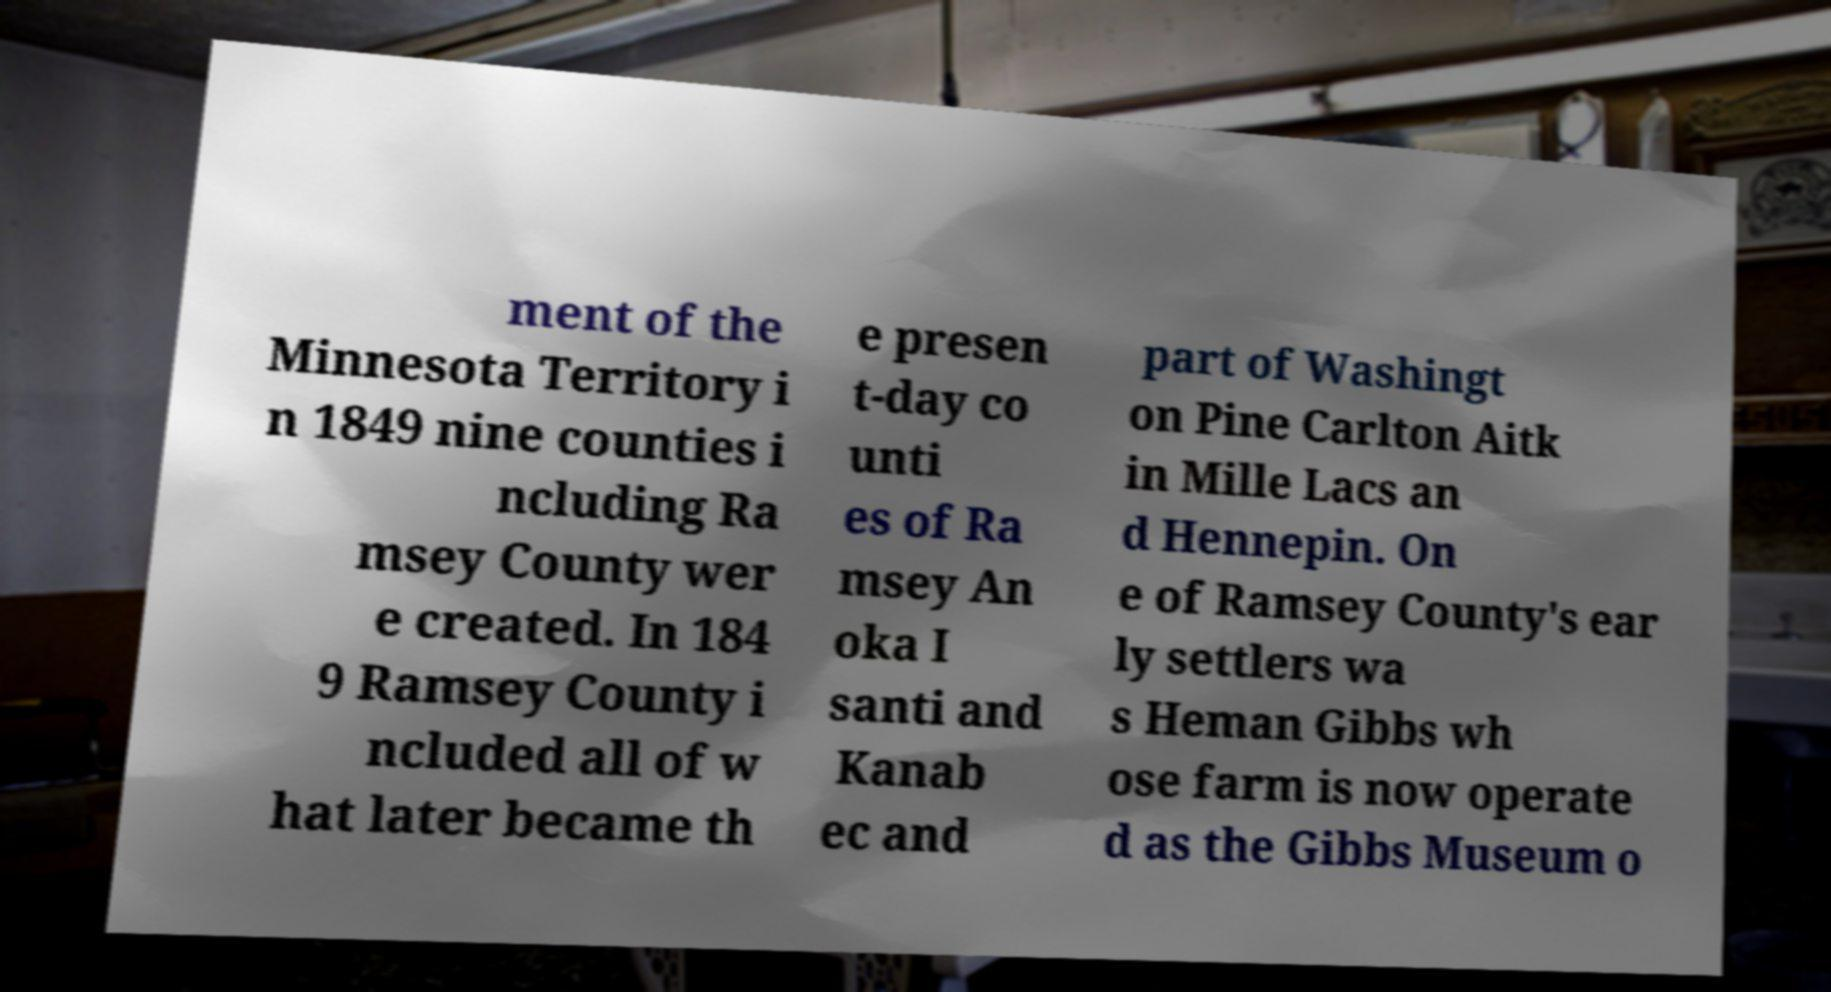I need the written content from this picture converted into text. Can you do that? ment of the Minnesota Territory i n 1849 nine counties i ncluding Ra msey County wer e created. In 184 9 Ramsey County i ncluded all of w hat later became th e presen t-day co unti es of Ra msey An oka I santi and Kanab ec and part of Washingt on Pine Carlton Aitk in Mille Lacs an d Hennepin. On e of Ramsey County's ear ly settlers wa s Heman Gibbs wh ose farm is now operate d as the Gibbs Museum o 